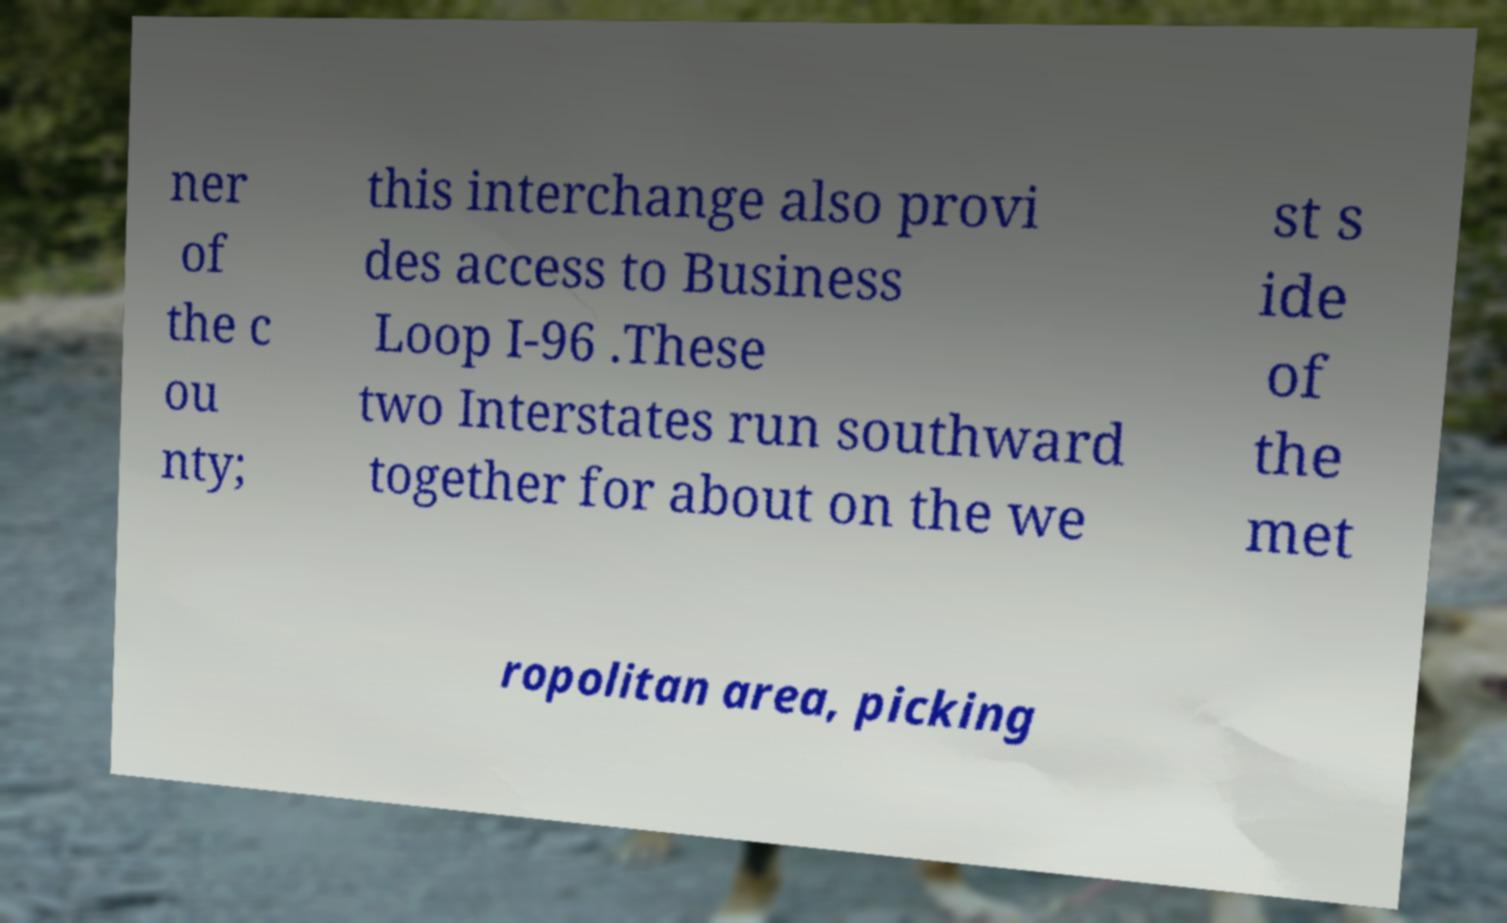Please read and relay the text visible in this image. What does it say? ner of the c ou nty; this interchange also provi des access to Business Loop I-96 .These two Interstates run southward together for about on the we st s ide of the met ropolitan area, picking 